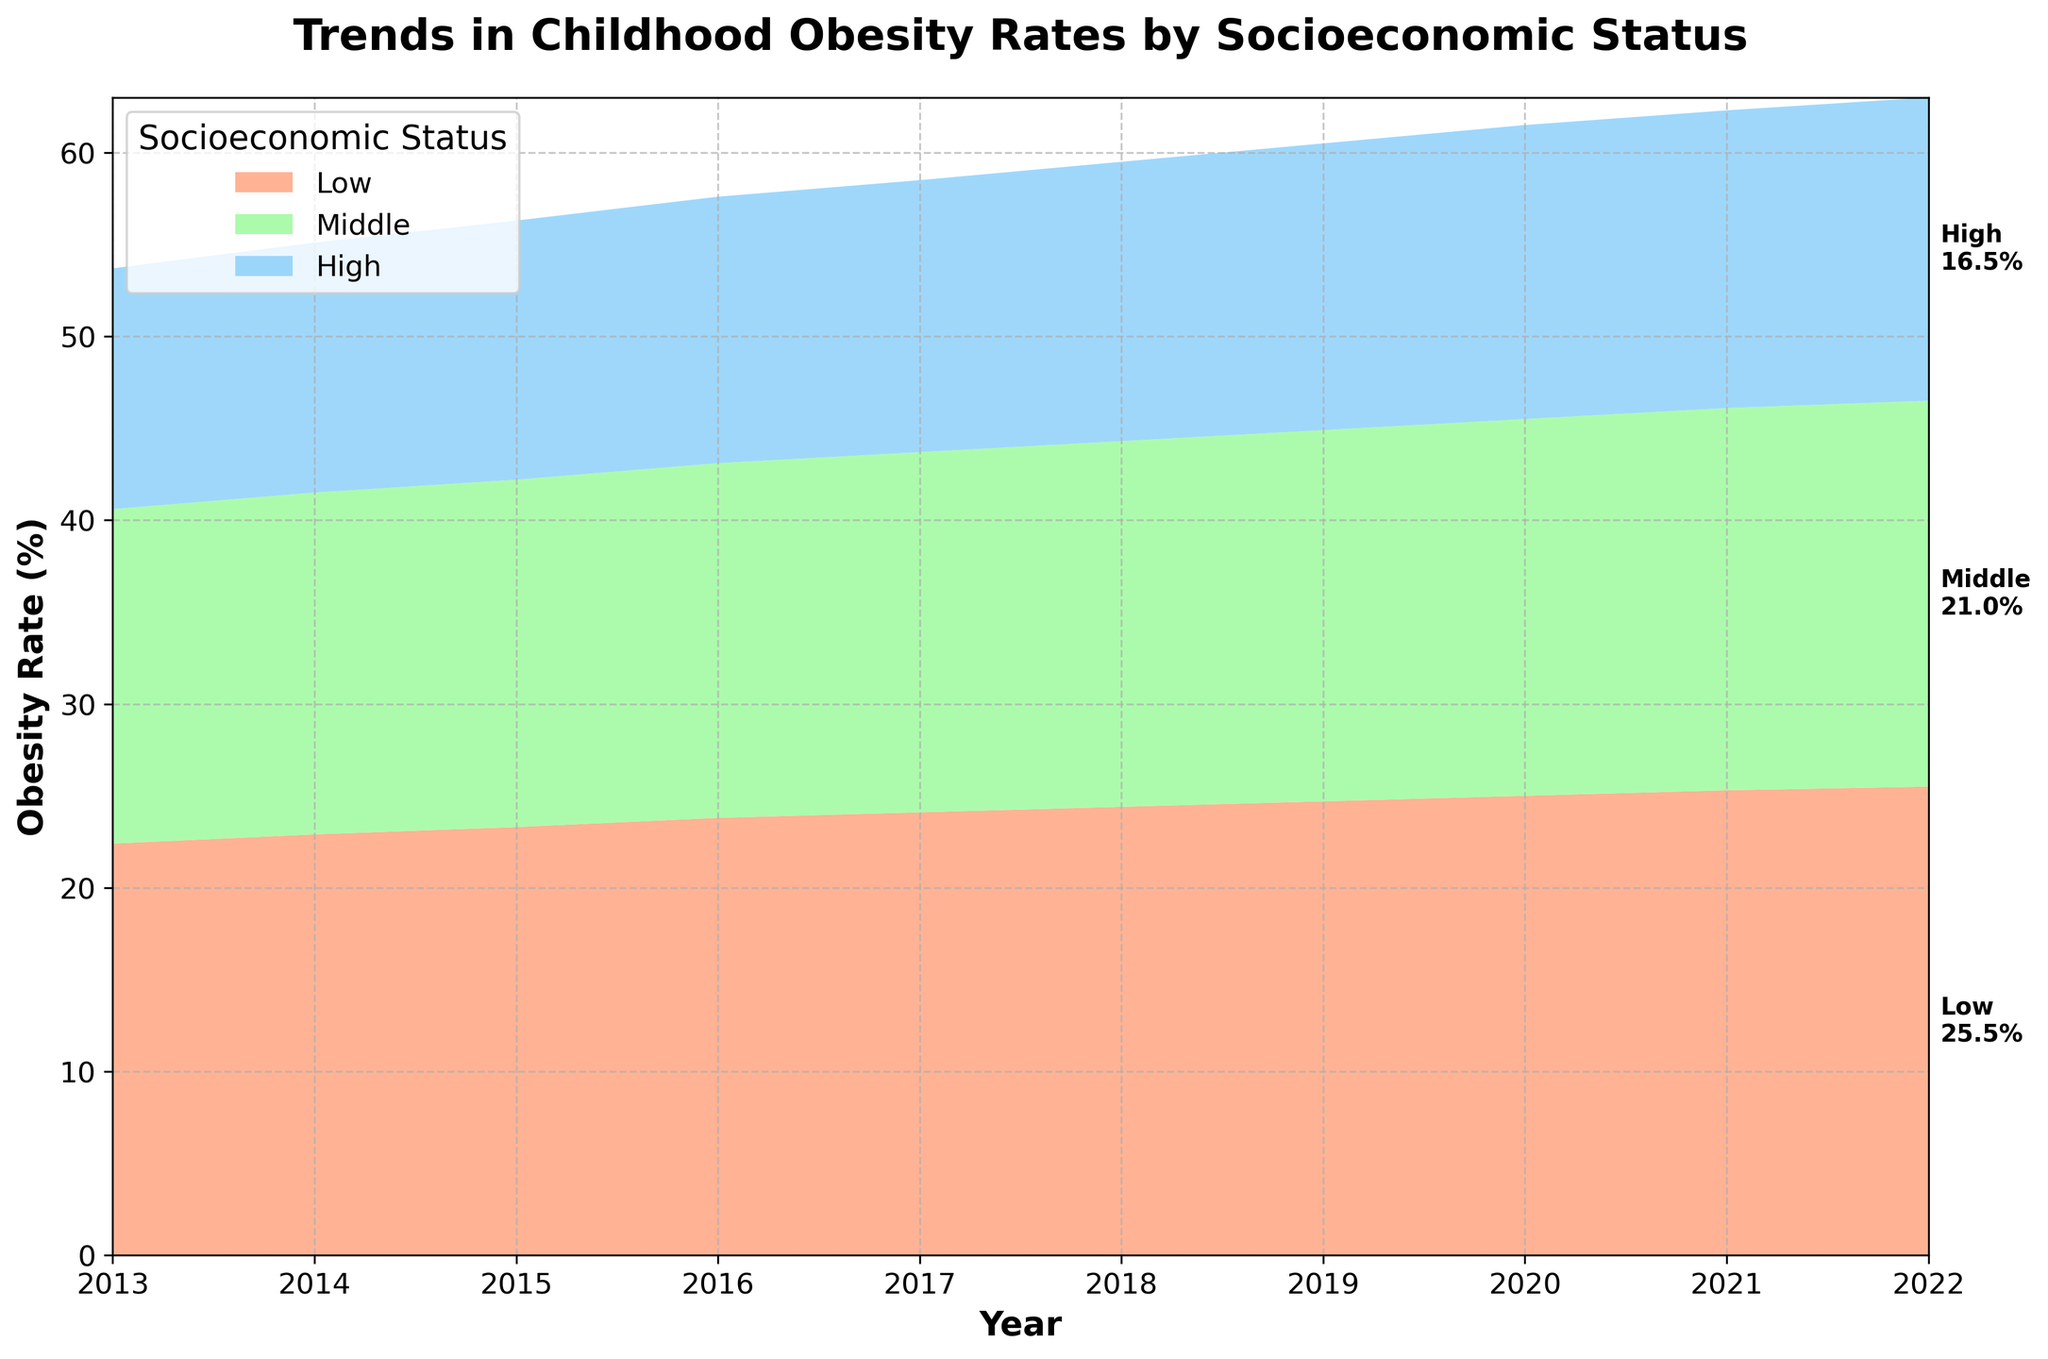What is the title of the figure? The title is usually located at the top of the figure. Here, it is visible as "Trends in Childhood Obesity Rates by Socioeconomic Status".
Answer: Trends in Childhood Obesity Rates by Socioeconomic Status What are the years displayed on the x-axis? The x-axis typically represents the range of years for the data. From the figure, it spans from 2013 to 2022.
Answer: 2013 to 2022 Which socioeconomic status had the highest obesity rate in 2022? To find this, look at the obesity rates for each status in 2022. The "Low" status shows the highest rate at 25.5%.
Answer: Low How did the obesity rate for the "Middle" socioeconomic status change from 2013 to 2022? Compare the starting rate in 2013 (18.2%) with the ending rate in 2022 (21.0%). Subtract the starting rate from the ending rate. 21.0% - 18.2% = 2.8%.
Answer: Increased by 2.8% Between which years did the "High" socioeconomic status see the most significant increase in obesity rate? Look at the incremental increases each year for the "High" status. The largest increase occurs between 2019 (15.6%) and 2020 (16.0%), which is an increase of 0.4%.
Answer: 2019 and 2020 What is the total sum of the obesity rates for "High" status from 2013 to 2022? Add the obesity rates for "High" from each year: 13.1 + 13.6 + 14.1 + 14.5 + 14.8 + 15.2 + 15.6 + 16.0 + 16.2 + 16.5 = 149.6%.
Answer: 149.6% How does the trend for the "Low" socioeconomic status compare to the trend for the "High" status over the decade? Examine the general direction and rate of change for both statuses. "Low" shows a steep increase from 22.4% to 25.5%, while "High" shows a gradual increase from 13.1% to 16.5%. The rate of increase for "Low" is more pronounced.
Answer: "Low" increased more steeply than "High" What pattern do you observe in the obesity rates for "Middle" socioeconomic status over the observed years? Analyze the line or area representing the "Middle" status. It shows a consistent upward trend from 18.2% to 21.0%.
Answer: Steady increase How much did the obesity rate for the "High" socioeconomic status increase on average each year from 2013 to 2022? Calculate the total increase (16.5% - 13.1% = 3.4%) and divide by the number of years (2022 - 2013 = 9). Average increase per year = 3.4% / 9 ≈ 0.38%.
Answer: 0.38% Which socioeconomic status had the smallest change in obesity rate over the decade? Compare the total changes in rates for each status. "High" status had the smallest change from 13.1% to 16.5%, which is a change of 3.4%.
Answer: High 